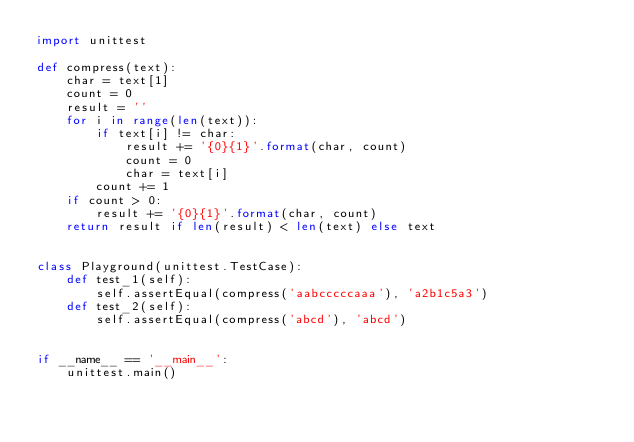Convert code to text. <code><loc_0><loc_0><loc_500><loc_500><_Python_>import unittest

def compress(text):
    char = text[1]
    count = 0
    result = ''
    for i in range(len(text)):
        if text[i] != char:
            result += '{0}{1}'.format(char, count)
            count = 0
            char = text[i]
        count += 1
    if count > 0:
        result += '{0}{1}'.format(char, count)
    return result if len(result) < len(text) else text


class Playground(unittest.TestCase):
    def test_1(self):
        self.assertEqual(compress('aabcccccaaa'), 'a2b1c5a3')
    def test_2(self):
        self.assertEqual(compress('abcd'), 'abcd')


if __name__ == '__main__':
    unittest.main()
</code> 